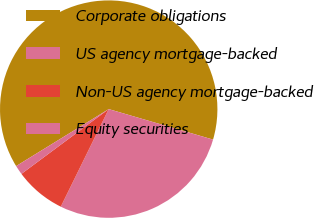<chart> <loc_0><loc_0><loc_500><loc_500><pie_chart><fcel>Corporate obligations<fcel>US agency mortgage-backed<fcel>Non-US agency mortgage-backed<fcel>Equity securities<nl><fcel>63.3%<fcel>27.74%<fcel>7.57%<fcel>1.38%<nl></chart> 